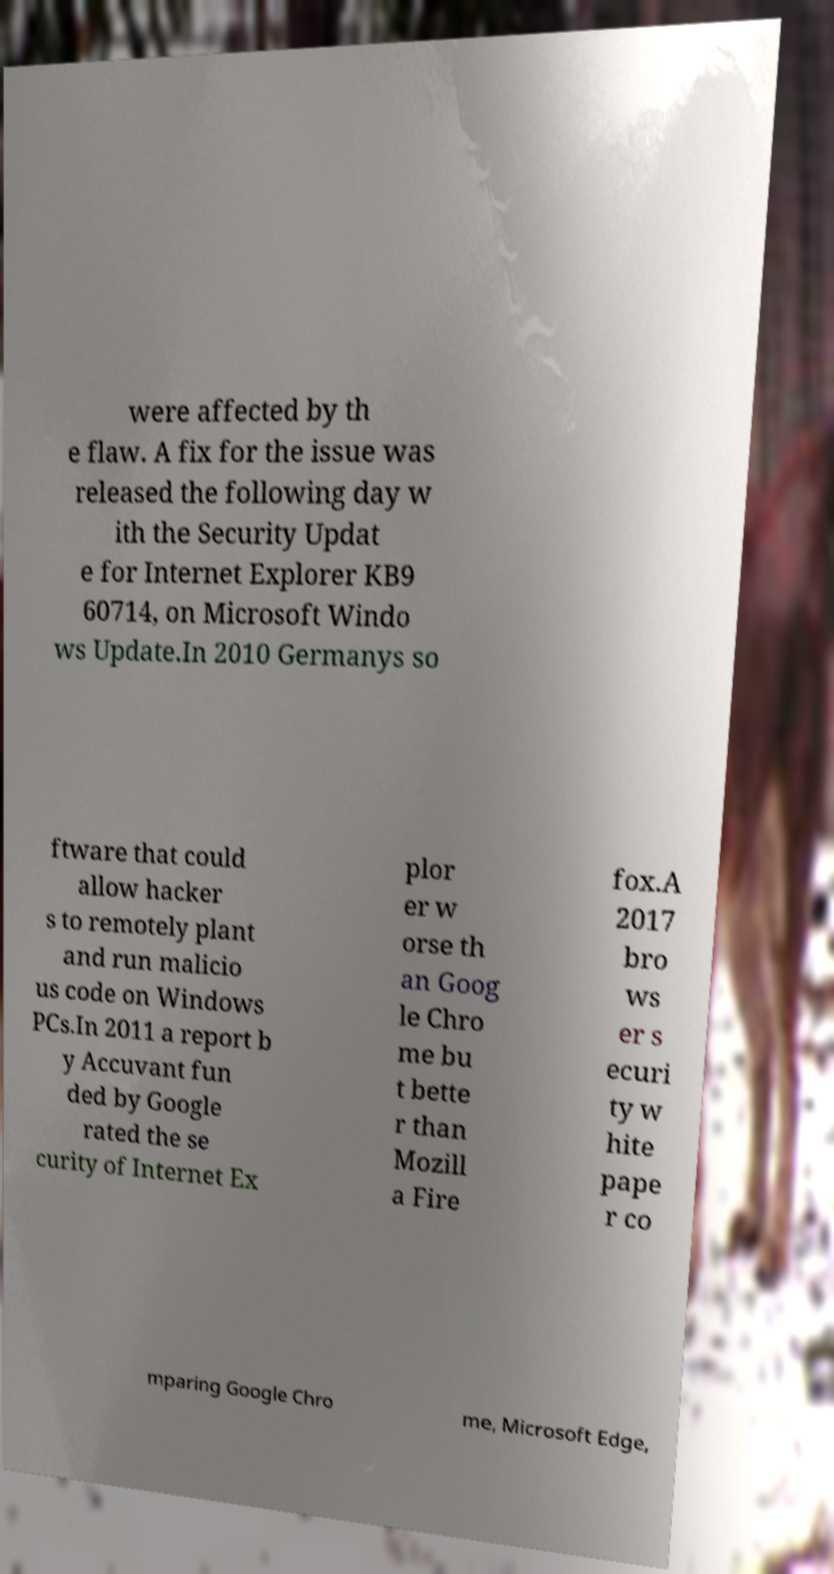I need the written content from this picture converted into text. Can you do that? were affected by th e flaw. A fix for the issue was released the following day w ith the Security Updat e for Internet Explorer KB9 60714, on Microsoft Windo ws Update.In 2010 Germanys so ftware that could allow hacker s to remotely plant and run malicio us code on Windows PCs.In 2011 a report b y Accuvant fun ded by Google rated the se curity of Internet Ex plor er w orse th an Goog le Chro me bu t bette r than Mozill a Fire fox.A 2017 bro ws er s ecuri ty w hite pape r co mparing Google Chro me, Microsoft Edge, 